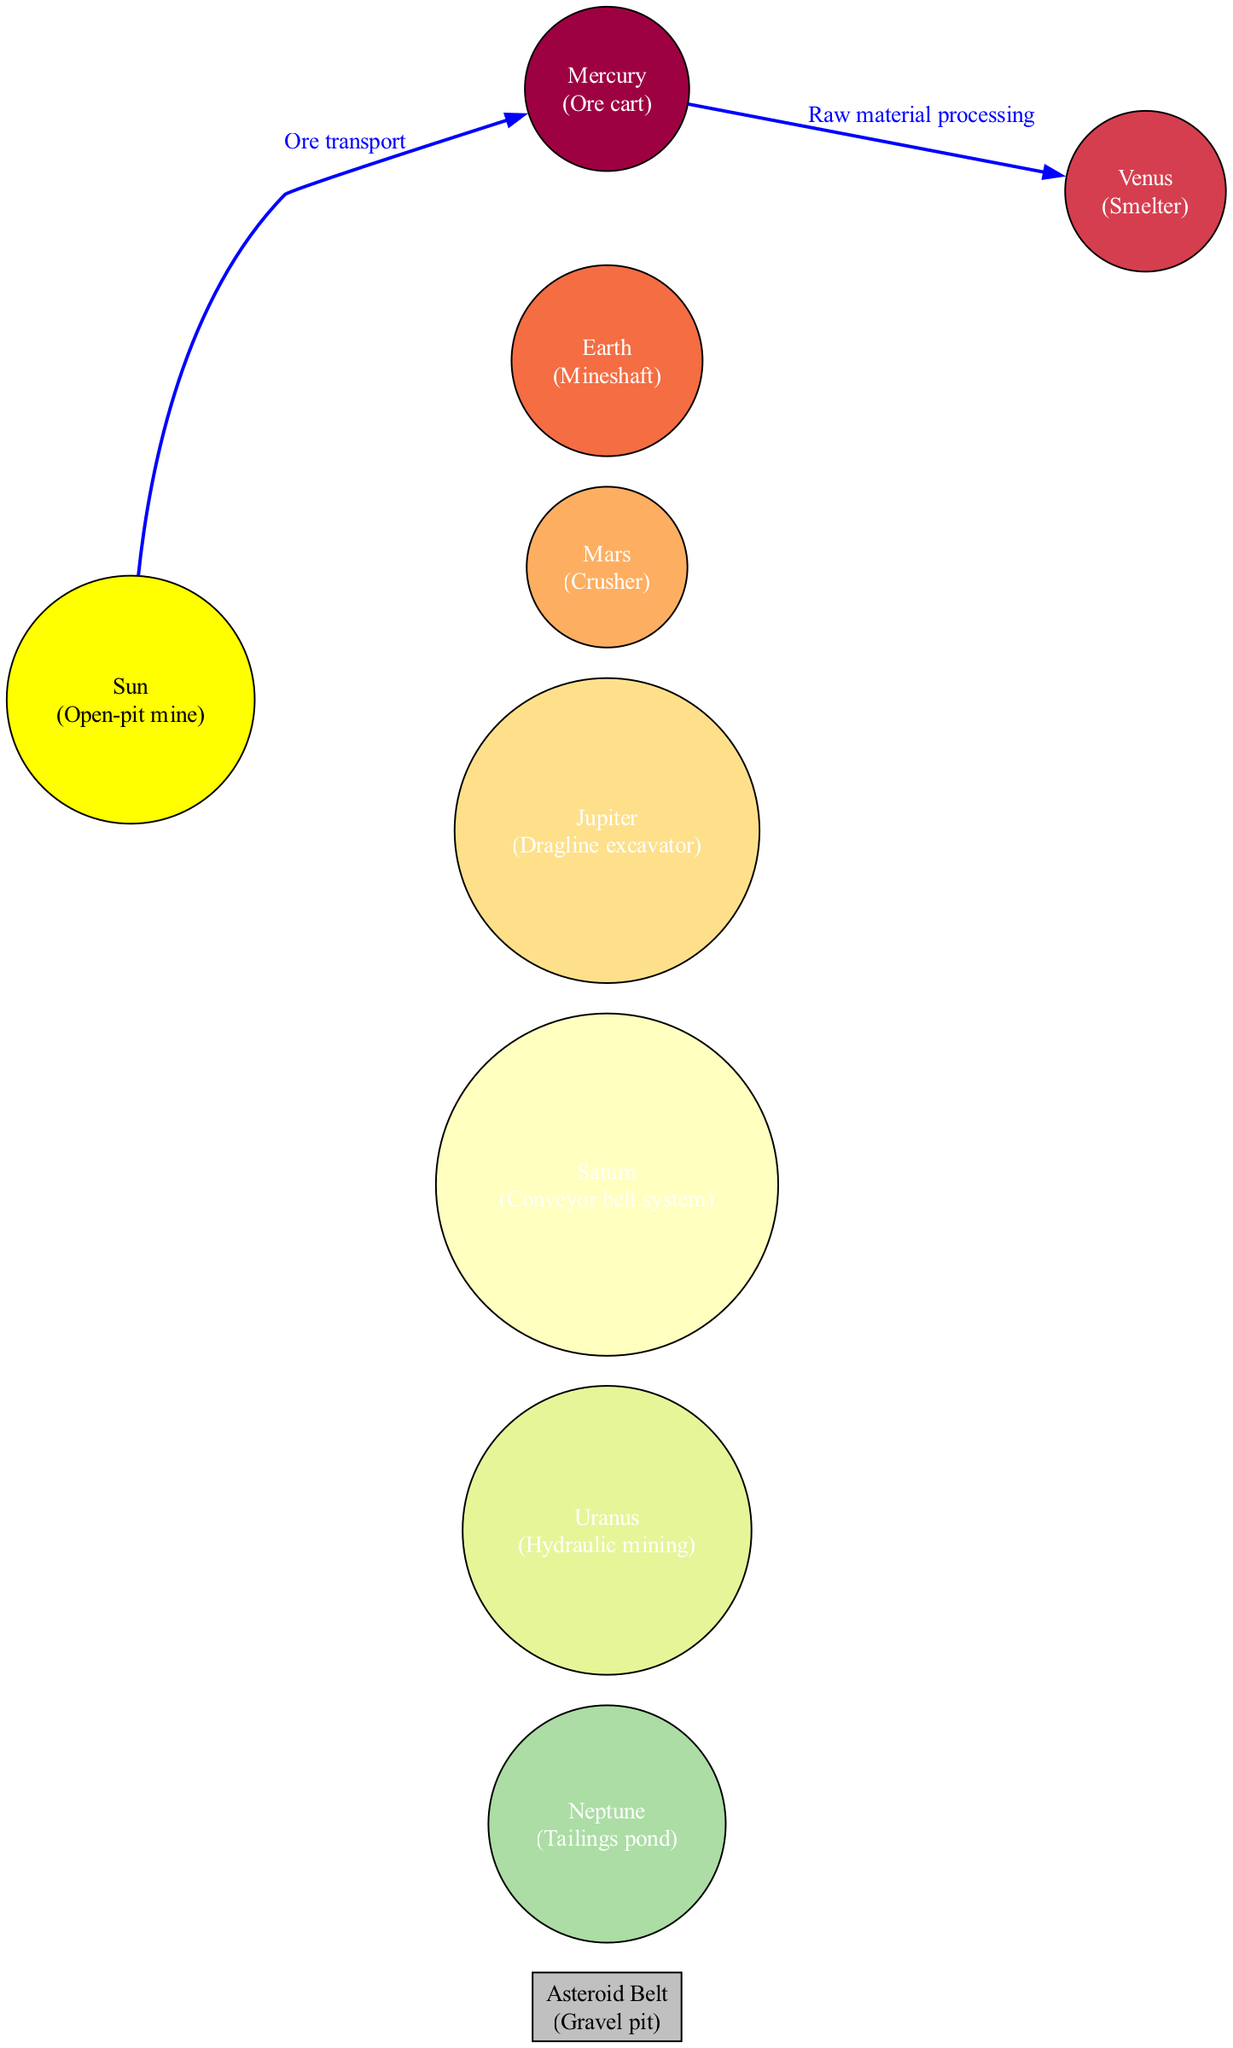What is the central object in the diagram? The central object is labeled as "Sun," which is depicted as an open-pit mine.
Answer: Sun How many planets are illustrated in the diagram? The diagram displays eight planets, each represented with analogies related to mining operations and equipment.
Answer: 8 Which planet is compared to a smelter? Venus is referred to as a smelter, indicating its role in processing raw materials.
Answer: Venus What is the description of the asteroid belt? The asteroid belt is described as a gravel pit, paralleling its function as a collection of debris, much like a pit in mining operations.
Answer: Gravel pit What type of mining operation is Uranus associated with? Uranus is associated with hydraulic mining, which is a technique used in extracting valuable minerals from the earth.
Answer: Hydraulic mining How is Mercury related to the Sun? Mercury's relationship to the Sun is described as ore transport, highlighting a connection analogous to the transport of mined materials from the primary source.
Answer: Ore transport What is the relationship between Mercury and Venus? The connection between Mercury and Venus is described as raw material processing, indicating the step that transforms raw mined materials as they move between these two entities.
Answer: Raw material processing Which mining equipment is associated with Jupiter? Jupiter is likened to a dragline excavator, emphasizing its massive size and the significant role it plays within this mining analogy.
Answer: Dragline excavator What type of mining process does Mars represent? Mars represents a crusher, which is typically used to break down large materials into smaller, manageable pieces in the mining industry.
Answer: Crusher 